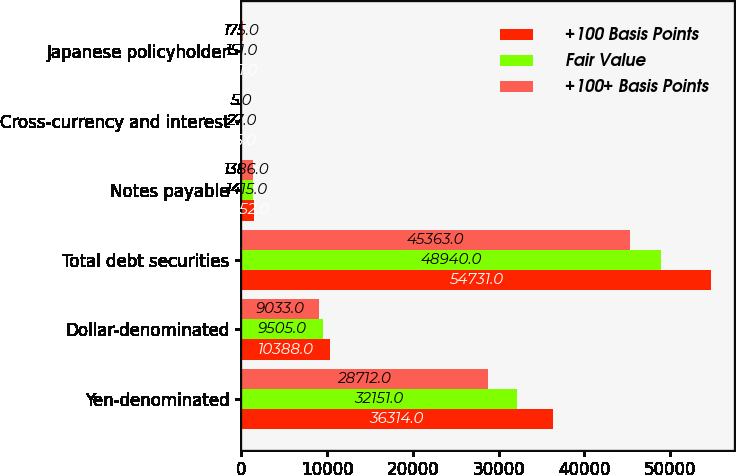Convert chart to OTSL. <chart><loc_0><loc_0><loc_500><loc_500><stacked_bar_chart><ecel><fcel>Yen-denominated<fcel>Dollar-denominated<fcel>Total debt securities<fcel>Notes payable<fcel>Cross-currency and interest<fcel>Japanese policyholder<nl><fcel>+100 Basis Points<fcel>36314<fcel>10388<fcel>54731<fcel>1452<fcel>35<fcel>151<nl><fcel>Fair Value<fcel>32151<fcel>9505<fcel>48940<fcel>1415<fcel>27<fcel>151<nl><fcel>+100+ Basis Points<fcel>28712<fcel>9033<fcel>45363<fcel>1386<fcel>5<fcel>175<nl></chart> 